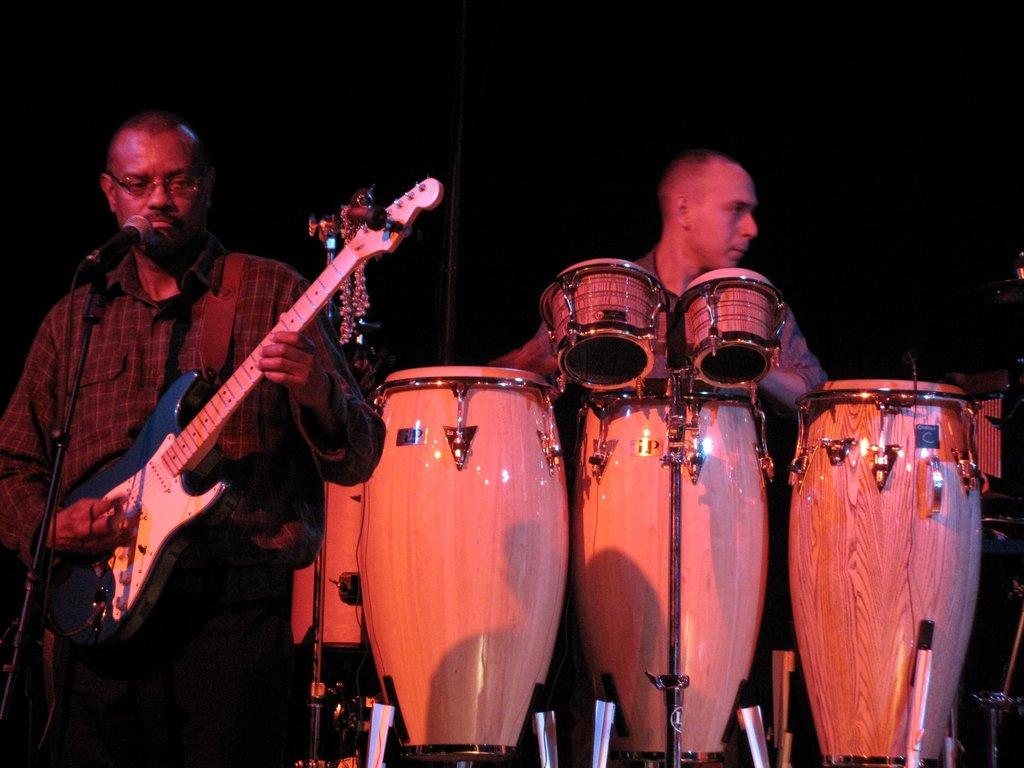How many people are in the image? There are two persons in the image. What are the two persons doing in the image? The two persons are playing musical instruments. What type of existence is depicted in the image? The image does not depict any specific type of existence; it simply shows two persons playing musical instruments. How many quarters can be seen in the image? There are no quarters present in the image. 